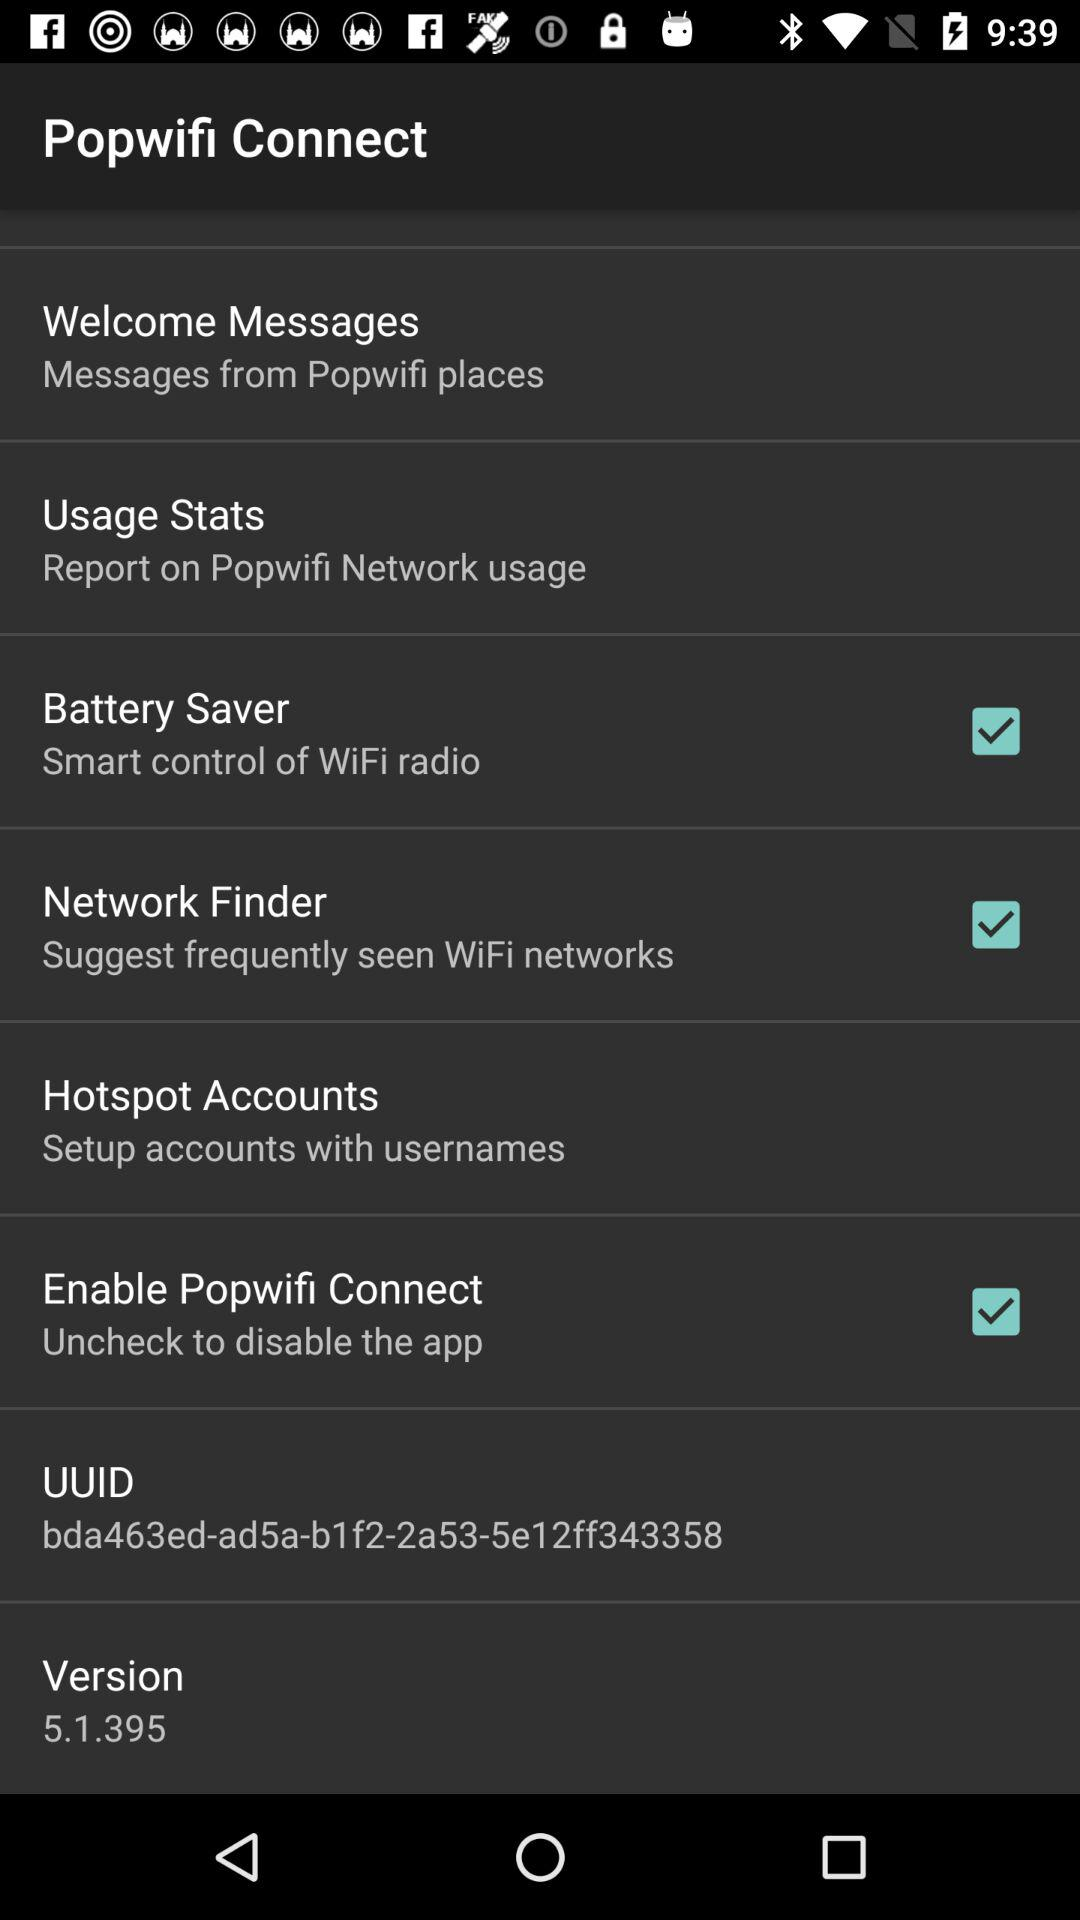What is the version? The version is 5.1.395. 